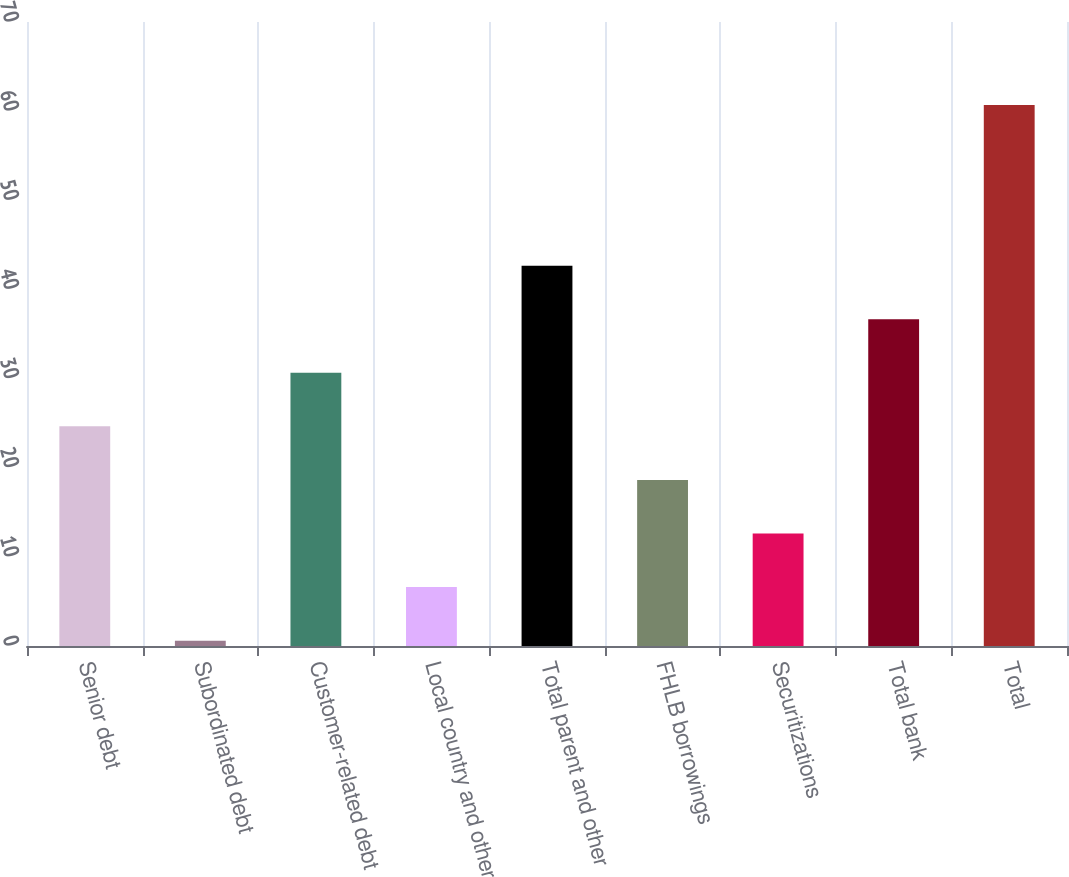Convert chart to OTSL. <chart><loc_0><loc_0><loc_500><loc_500><bar_chart><fcel>Senior debt<fcel>Subordinated debt<fcel>Customer-related debt<fcel>Local country and other<fcel>Total parent and other<fcel>FHLB borrowings<fcel>Securitizations<fcel>Total bank<fcel>Total<nl><fcel>24.64<fcel>0.6<fcel>30.65<fcel>6.61<fcel>42.67<fcel>18.63<fcel>12.62<fcel>36.66<fcel>60.7<nl></chart> 